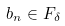<formula> <loc_0><loc_0><loc_500><loc_500>b _ { n } \in F _ { \delta }</formula> 